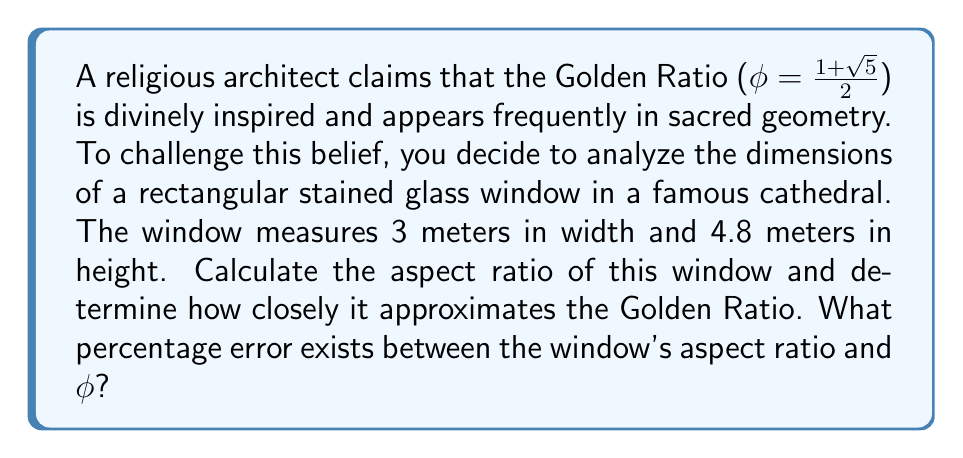Give your solution to this math problem. To approach this problem scientifically, we'll follow these steps:

1) Calculate the aspect ratio of the window:
   Aspect ratio = Height / Width
   $$ \text{Aspect ratio} = \frac{4.8 \text{ m}}{3 \text{ m}} = 1.6 $$

2) Recall the value of the Golden Ratio:
   $$ \phi = \frac{1+\sqrt{5}}{2} \approx 1.618034 $$

3) Calculate the percentage error:
   $$ \text{Percentage Error} = \left|\frac{\text{Approximate Value} - \text{Exact Value}}{\text{Exact Value}}\right| \times 100\% $$
   
   $$ \text{Percentage Error} = \left|\frac{1.6 - 1.618034}{1.618034}\right| \times 100\% $$
   
   $$ \text{Percentage Error} = \left|\frac{-0.018034}{1.618034}\right| \times 100\% $$
   
   $$ \text{Percentage Error} = 0.011144 \times 100\% = 1.1144\% $$

This analysis shows that while the window's proportions are close to the Golden Ratio, they do not exactly match it. The difference is small (about 1.11%), but it's measurable and significant in precise geometric analysis.
Answer: The percentage error between the window's aspect ratio and the Golden Ratio is approximately 1.11%. 